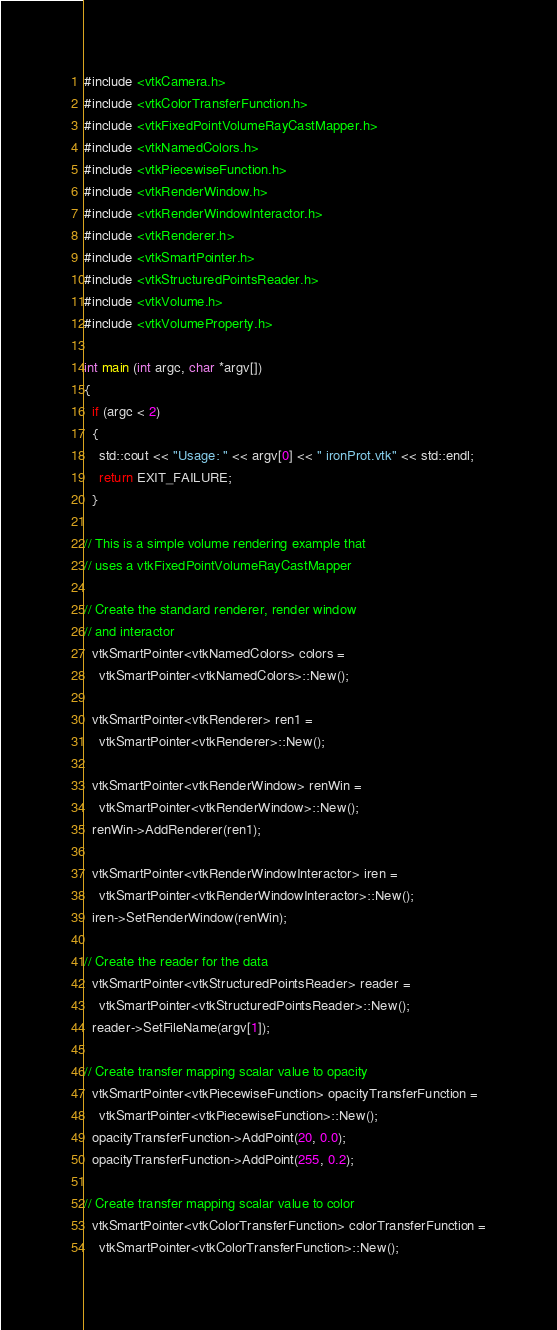Convert code to text. <code><loc_0><loc_0><loc_500><loc_500><_C++_>#include <vtkCamera.h>
#include <vtkColorTransferFunction.h>
#include <vtkFixedPointVolumeRayCastMapper.h>
#include <vtkNamedColors.h>
#include <vtkPiecewiseFunction.h>
#include <vtkRenderWindow.h>
#include <vtkRenderWindowInteractor.h>
#include <vtkRenderer.h>
#include <vtkSmartPointer.h>
#include <vtkStructuredPointsReader.h>
#include <vtkVolume.h>
#include <vtkVolumeProperty.h>

int main (int argc, char *argv[])
{
  if (argc < 2)
  {
    std::cout << "Usage: " << argv[0] << " ironProt.vtk" << std::endl;
    return EXIT_FAILURE;
  }

// This is a simple volume rendering example that
// uses a vtkFixedPointVolumeRayCastMapper

// Create the standard renderer, render window
// and interactor
  vtkSmartPointer<vtkNamedColors> colors =
    vtkSmartPointer<vtkNamedColors>::New();

  vtkSmartPointer<vtkRenderer> ren1 =
    vtkSmartPointer<vtkRenderer>::New();

  vtkSmartPointer<vtkRenderWindow> renWin =
    vtkSmartPointer<vtkRenderWindow>::New();
  renWin->AddRenderer(ren1);

  vtkSmartPointer<vtkRenderWindowInteractor> iren =
    vtkSmartPointer<vtkRenderWindowInteractor>::New();
  iren->SetRenderWindow(renWin);

// Create the reader for the data
  vtkSmartPointer<vtkStructuredPointsReader> reader =
    vtkSmartPointer<vtkStructuredPointsReader>::New();
  reader->SetFileName(argv[1]);

// Create transfer mapping scalar value to opacity
  vtkSmartPointer<vtkPiecewiseFunction> opacityTransferFunction =
    vtkSmartPointer<vtkPiecewiseFunction>::New();
  opacityTransferFunction->AddPoint(20, 0.0);
  opacityTransferFunction->AddPoint(255, 0.2);

// Create transfer mapping scalar value to color
  vtkSmartPointer<vtkColorTransferFunction> colorTransferFunction =
    vtkSmartPointer<vtkColorTransferFunction>::New();</code> 